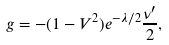<formula> <loc_0><loc_0><loc_500><loc_500>g = - ( 1 - V ^ { 2 } ) e ^ { - \lambda / 2 } \frac { \nu ^ { \prime } } { 2 } ,</formula> 